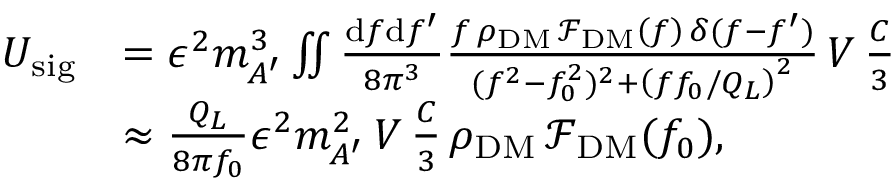<formula> <loc_0><loc_0><loc_500><loc_500>\begin{array} { r l } { U _ { s i g } } & { = \epsilon ^ { 2 } m _ { A ^ { \prime } } ^ { 3 } \iint \frac { d f d f ^ { \prime } } { 8 \pi ^ { 3 } } \frac { f \, \rho _ { D M } \, \mathcal { F } _ { D M } \left ( f \right ) \, \delta ( f - f ^ { \prime } ) } { ( f ^ { 2 } - f _ { 0 } ^ { 2 } ) ^ { 2 } + \left ( f f _ { 0 } / Q _ { L } \right ) ^ { 2 } } \, V \, \frac { C } { 3 } } \\ & { \approx \frac { Q _ { L } } { 8 \pi f _ { 0 } } \epsilon ^ { 2 } m _ { A ^ { \prime } } ^ { 2 } \, V \, \frac { C } { 3 } \, \rho _ { D M } \, \mathcal { F } _ { D M } ( f _ { 0 } ) , } \end{array}</formula> 